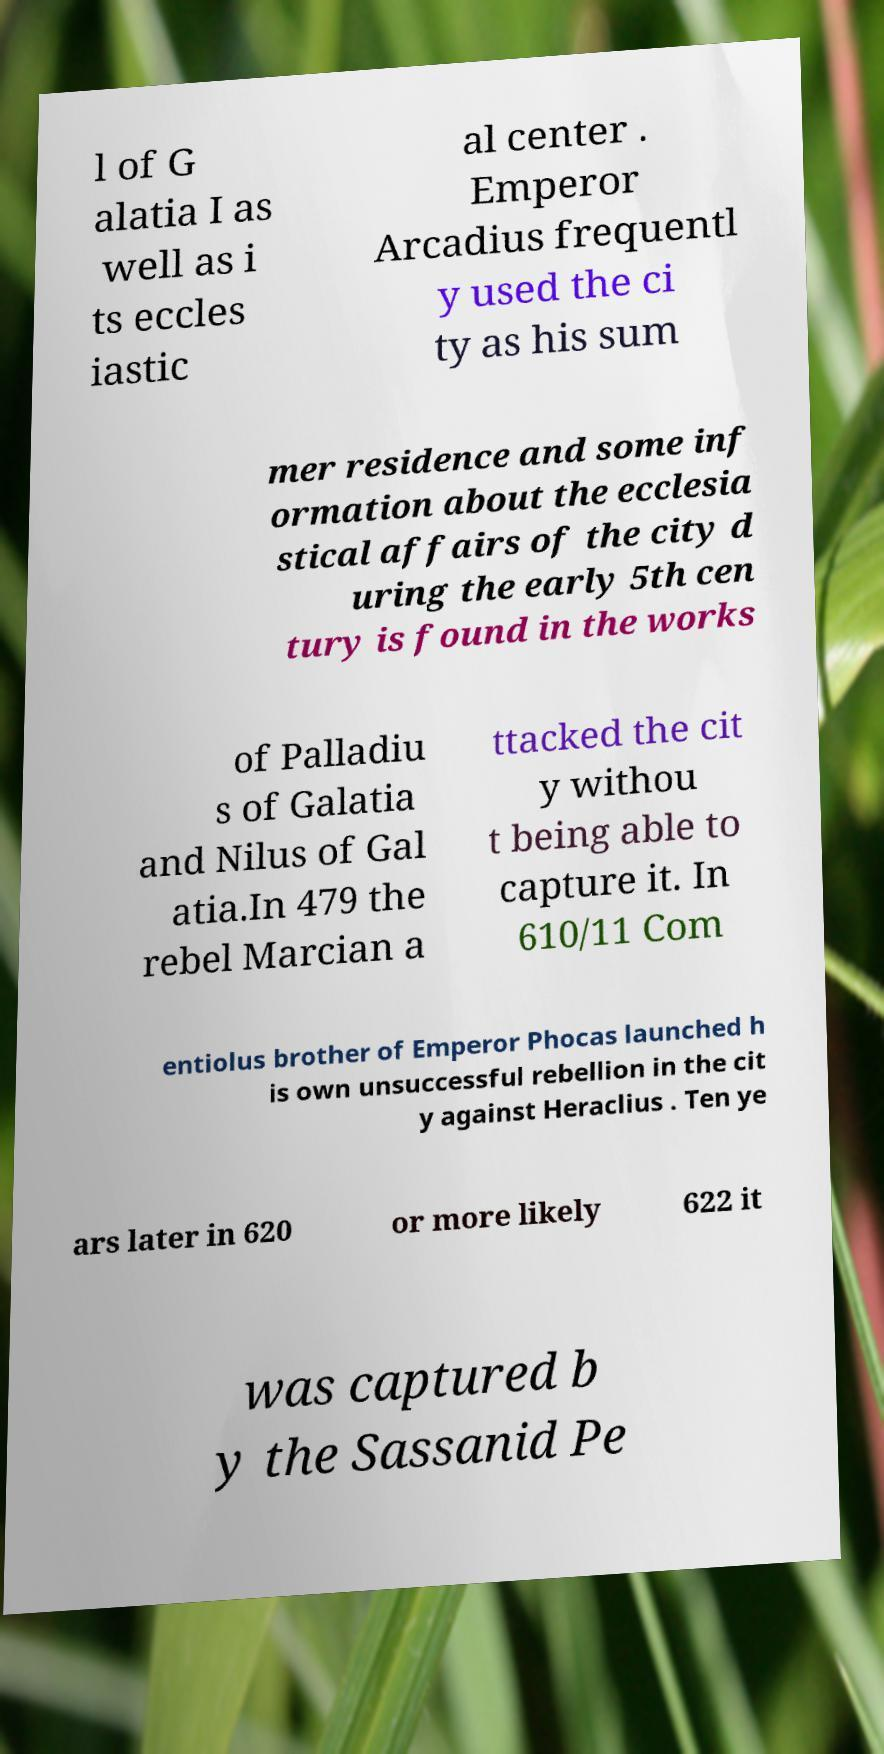What messages or text are displayed in this image? I need them in a readable, typed format. l of G alatia I as well as i ts eccles iastic al center . Emperor Arcadius frequentl y used the ci ty as his sum mer residence and some inf ormation about the ecclesia stical affairs of the city d uring the early 5th cen tury is found in the works of Palladiu s of Galatia and Nilus of Gal atia.In 479 the rebel Marcian a ttacked the cit y withou t being able to capture it. In 610/11 Com entiolus brother of Emperor Phocas launched h is own unsuccessful rebellion in the cit y against Heraclius . Ten ye ars later in 620 or more likely 622 it was captured b y the Sassanid Pe 